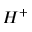<formula> <loc_0><loc_0><loc_500><loc_500>H ^ { + }</formula> 